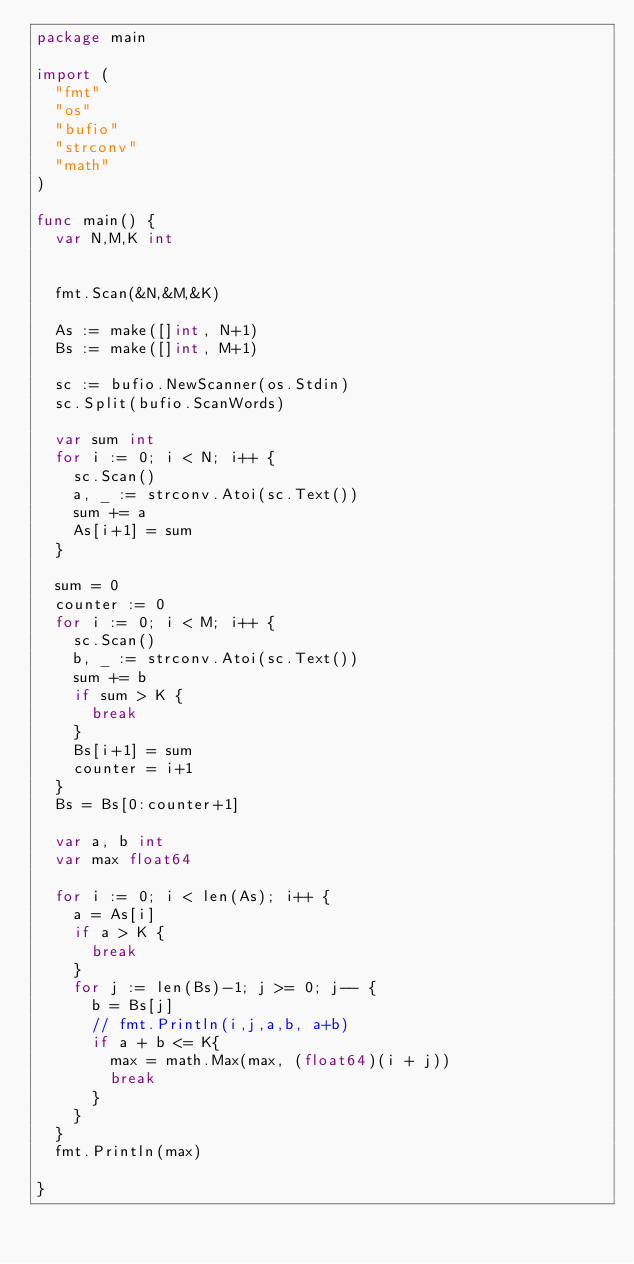<code> <loc_0><loc_0><loc_500><loc_500><_Go_>package main

import (
	"fmt"
	"os"
	"bufio"
	"strconv"
	"math"
)

func main() {
	var N,M,K int

	
	fmt.Scan(&N,&M,&K)

	As := make([]int, N+1)
	Bs := make([]int, M+1)

	sc := bufio.NewScanner(os.Stdin)
	sc.Split(bufio.ScanWords)

	var sum int
	for i := 0; i < N; i++ {
		sc.Scan()
		a, _ := strconv.Atoi(sc.Text())
		sum += a
		As[i+1] = sum		
	}

	sum = 0
	counter := 0
	for i := 0; i < M; i++ {
		sc.Scan()
		b, _ := strconv.Atoi(sc.Text())
		sum += b
		if sum > K {
			break
		}
		Bs[i+1] = sum
		counter = i+1
	}
	Bs = Bs[0:counter+1]

	var a, b int
	var max float64

	for i := 0; i < len(As); i++ {
		a = As[i]
		if a > K {
			break
		}
		for j := len(Bs)-1; j >= 0; j-- {
			b = Bs[j]
			// fmt.Println(i,j,a,b, a+b)
			if a + b <= K{
				max = math.Max(max, (float64)(i + j))
				break
			}
		}
	}
	fmt.Println(max)

}

</code> 